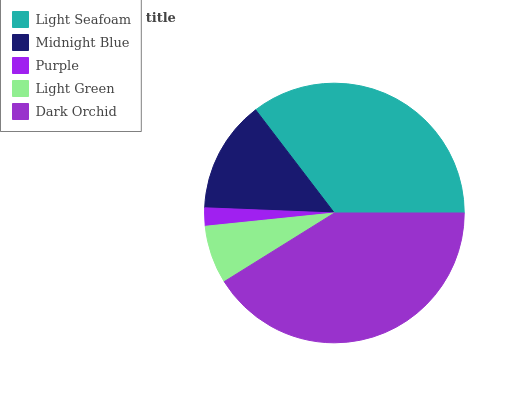Is Purple the minimum?
Answer yes or no. Yes. Is Dark Orchid the maximum?
Answer yes or no. Yes. Is Midnight Blue the minimum?
Answer yes or no. No. Is Midnight Blue the maximum?
Answer yes or no. No. Is Light Seafoam greater than Midnight Blue?
Answer yes or no. Yes. Is Midnight Blue less than Light Seafoam?
Answer yes or no. Yes. Is Midnight Blue greater than Light Seafoam?
Answer yes or no. No. Is Light Seafoam less than Midnight Blue?
Answer yes or no. No. Is Midnight Blue the high median?
Answer yes or no. Yes. Is Midnight Blue the low median?
Answer yes or no. Yes. Is Dark Orchid the high median?
Answer yes or no. No. Is Dark Orchid the low median?
Answer yes or no. No. 